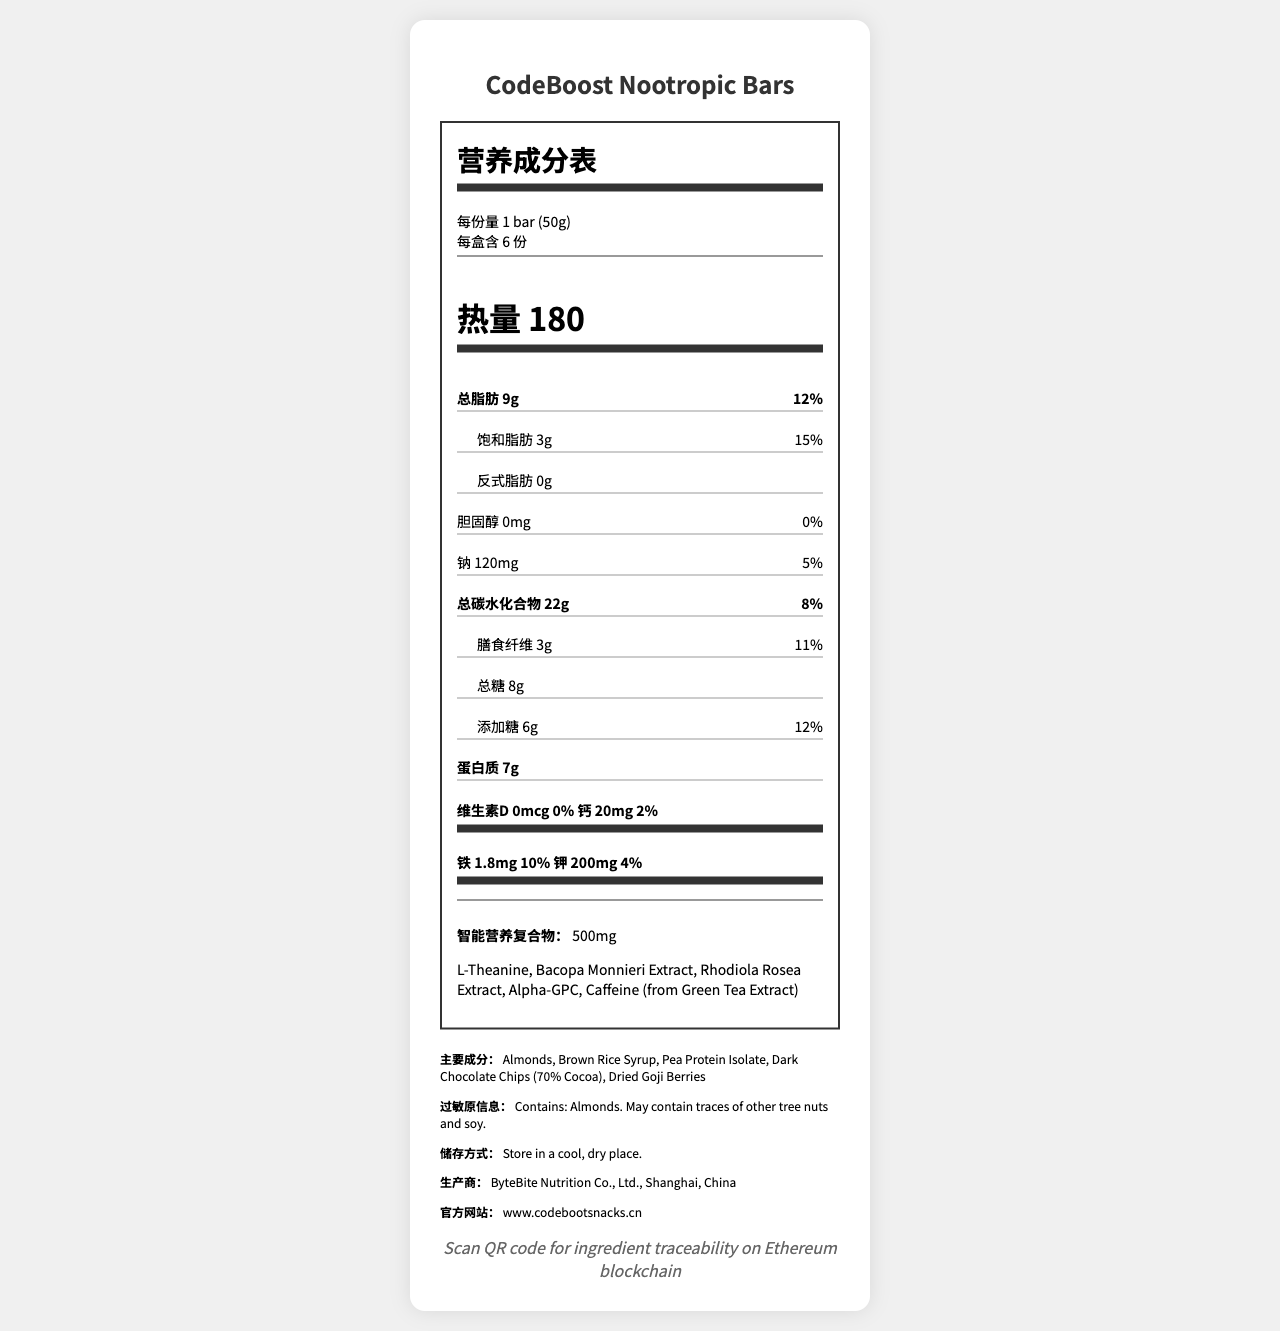what is the serving size? The serving size is listed as "1 bar (50g)" at the beginning of the document under "营养成分表" (Nutrition Facts).
Answer: 1 bar (50g) how many servings are in one container? The document states there are "每盒含 6 份" servings per container, which translates to 6 servings per container.
Answer: 6 how many grams of total fat does one bar contain? The total fat per serving is listed as "总脂肪 9g".
Answer: 9g what is the percentage daily value of saturated fat? The daily value percentage for saturated fat is given as "饱和脂肪 15%".
Answer: 15% how much protein is in each bar? The protein content per serving is listed as "蛋白质 7g".
Answer: 7g how many grams of dietary fiber does one bar have? The document lists "膳食纤维 3g" for dietary fiber, which translates to 3g.
Answer: 3g how much sodium is in one serving? The sodium content per serving is given as "钠 120mg".
Answer: 120mg What are the main ingredients? The main ingredients are listed under "主要成分".
Answer: Almonds, Brown Rice Syrup, Pea Protein Isolate, Dark Chocolate Chips (70% Cocoa), Dried Goji Berries which of the following is not a nootropic ingredient in the blend? A. L-Theanine B. Bacopa Monnieri Extract C. Honey D. Rhodiola Rosea Extract The nootropic blend includes L-Theanine, Bacopa Monnieri Extract, Rhodiola Rosea Extract, Alpha-GPC, and Caffeine (from Green Tea Extract), but not Honey.
Answer: C. Honey what is the website URL for more information? A. www.codeboostsnacks.com B. www.bytebite.cn C. www.codeboostsnacks.cn D. www.cppsnacks.cn The website URL given in the document is "www.codeboostsnacks.cn".
Answer: C. www.codeboostsnacks.cn does one serving contain any cholesterol? The document states "胆固醇 0mg" which means there is no cholesterol in one serving.
Answer: No is this product blockchain verified? The document includes a note saying "Scan QR code for ingredient traceability on Ethereum blockchain".
Answer: Yes summarize the main nutritional information provided in the document. The document provides nutritional details per serving, including calories, fats, carbohydrates, protein, vitamins, and minerals, along with information about the nootropic blend and main ingredients.
Answer: CodeBoost Nootropic Bars offer 180 calories per 50g bar, with 9g of total fat (including 3g saturated fat), 120mg of sodium, 22g of carbohydrates (including 3g of dietary fiber and 8g of sugars), and 7g of protein. The bars contain no cholesterol and provide small amounts of calcium, iron, and potassium. They also include a 500mg nootropic blend. how many grams of trans fat are there per bar? The trans fat content is listed as "反式脂肪 0g", which means 0g per serving.
Answer: 0g what is the daily value percentage for iron? The daily value percentage for iron is "铁 10%".
Answer: 10% does the document specify what type of drying process was used for goji berries? The document mentions "Dried Goji Berries" as a main ingredient but does not specify the drying process used.
Answer: Not enough information 